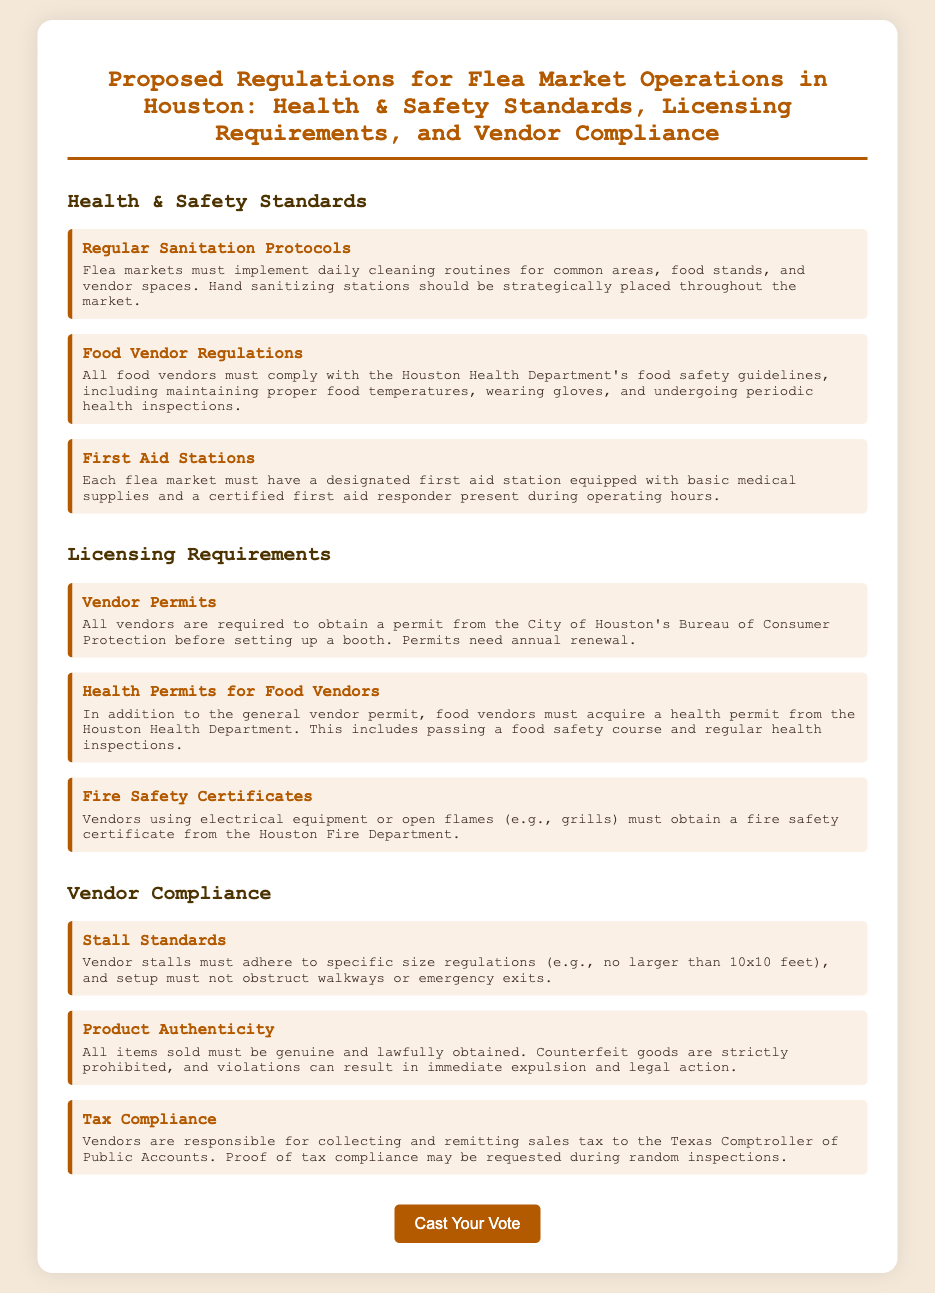What are the daily sanitation requirements? The document states that flea markets must implement daily cleaning routines for common areas, food stands, and vendor spaces.
Answer: daily cleaning routines What must food vendors comply with? Food vendors must comply with the Houston Health Department's food safety guidelines, including maintaining proper food temperatures, wearing gloves, and undergoing periodic health inspections.
Answer: Houston Health Department's food safety guidelines Is a health permit required for food vendors? The document specifies that food vendors must acquire a health permit from the Houston Health Department, which includes passing a food safety course.
Answer: Yes What size must vendor stalls adhere to? Vendor stalls must adhere to specific size regulations, as stated in the document.
Answer: 10x10 feet What type of goods are prohibited for sale? The document outlines that counterfeit goods are strictly prohibited.
Answer: Counterfeit goods How often do vendor permits need renewal? Vendor permits require annual renewal as indicated in the document.
Answer: annually How many first aid stations are required? Each flea market must have a designated first aid station as mentioned in the document.
Answer: One Which department issues fire safety certificates? The document mentions that the Houston Fire Department issues fire safety certificates.
Answer: Houston Fire Department What is the consequence of selling counterfeit goods? The document states that violations can result in immediate expulsion and legal action.
Answer: Immediate expulsion and legal action 